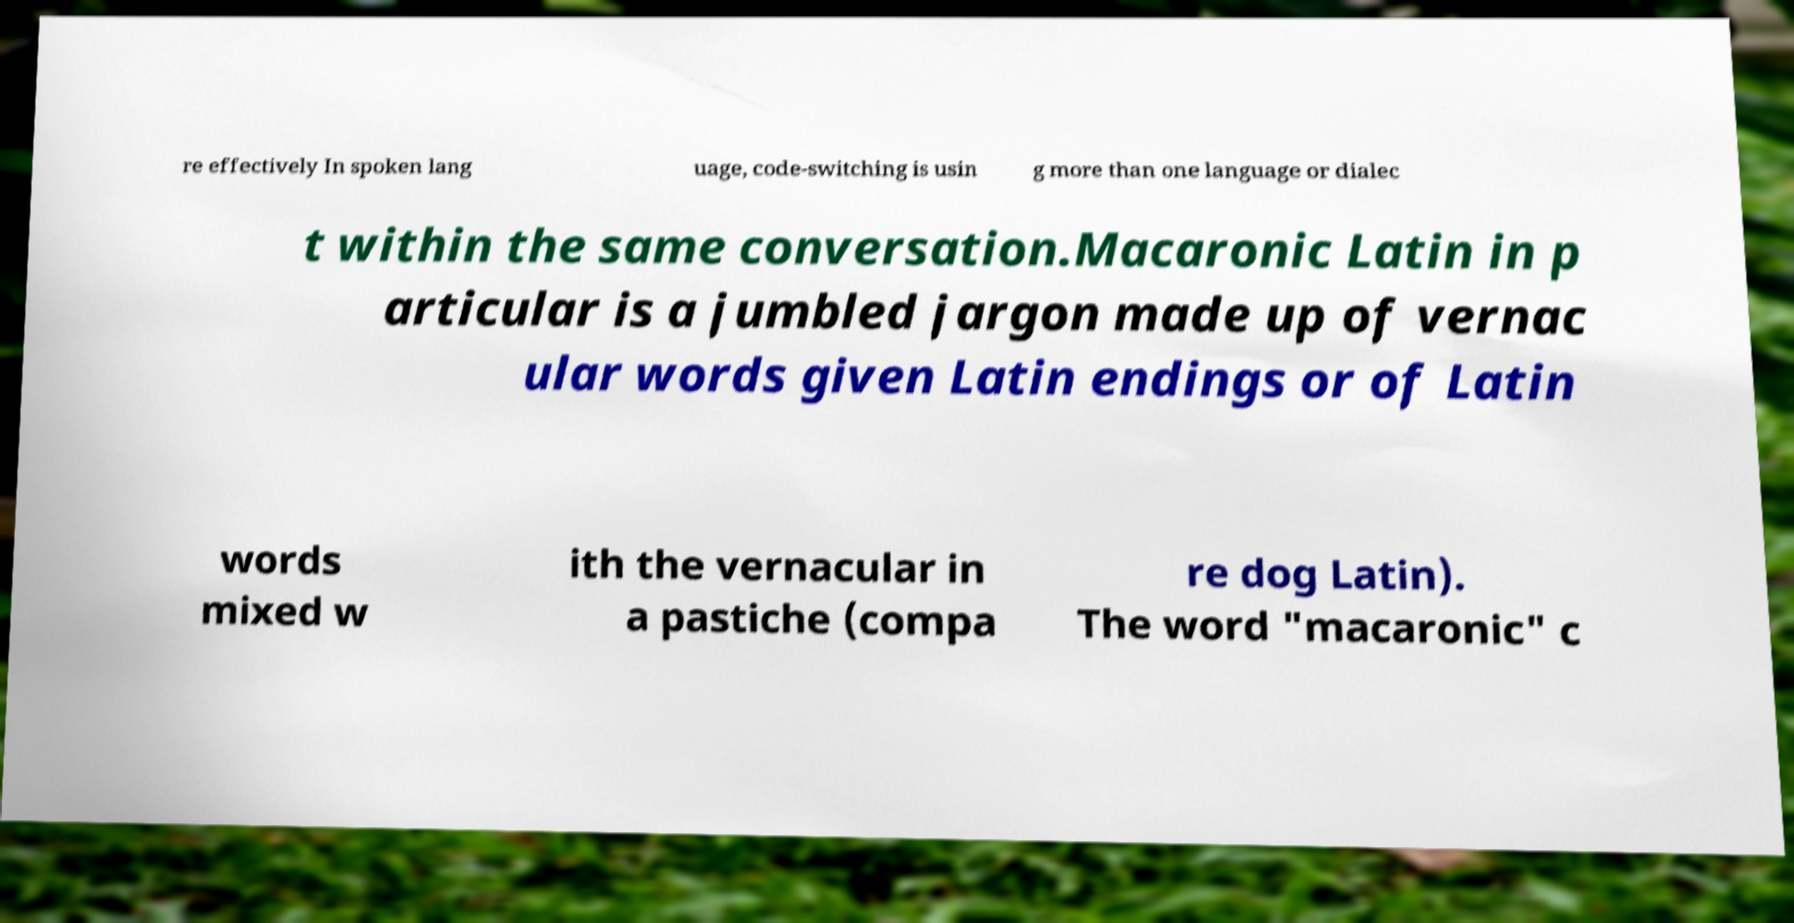Can you accurately transcribe the text from the provided image for me? re effectively In spoken lang uage, code-switching is usin g more than one language or dialec t within the same conversation.Macaronic Latin in p articular is a jumbled jargon made up of vernac ular words given Latin endings or of Latin words mixed w ith the vernacular in a pastiche (compa re dog Latin). The word "macaronic" c 